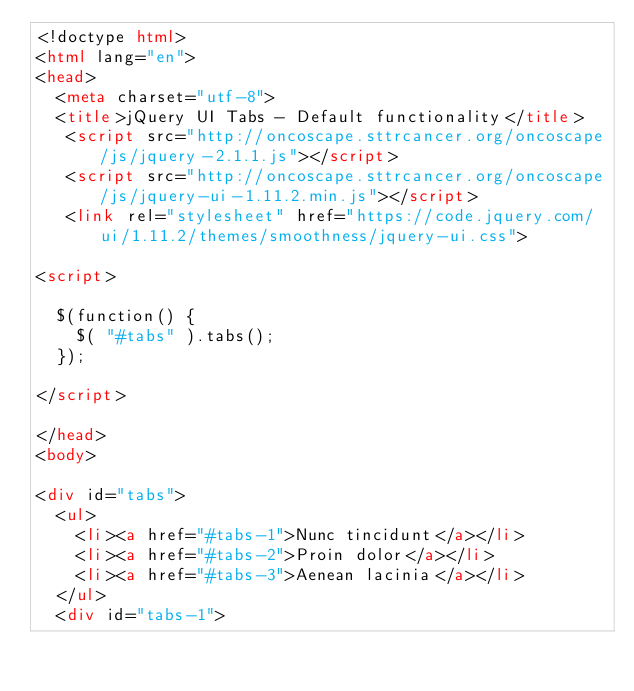Convert code to text. <code><loc_0><loc_0><loc_500><loc_500><_HTML_><!doctype html>
<html lang="en">
<head>
  <meta charset="utf-8">
  <title>jQuery UI Tabs - Default functionality</title>
   <script src="http://oncoscape.sttrcancer.org/oncoscape/js/jquery-2.1.1.js"></script>
   <script src="http://oncoscape.sttrcancer.org/oncoscape/js/jquery-ui-1.11.2.min.js"></script>
   <link rel="stylesheet" href="https://code.jquery.com/ui/1.11.2/themes/smoothness/jquery-ui.css">

<script>

  $(function() {
    $( "#tabs" ).tabs();
  });

</script>

</head>
<body>
 
<div id="tabs">
  <ul>
    <li><a href="#tabs-1">Nunc tincidunt</a></li>
    <li><a href="#tabs-2">Proin dolor</a></li>
    <li><a href="#tabs-3">Aenean lacinia</a></li>
  </ul>
  <div id="tabs-1"></code> 